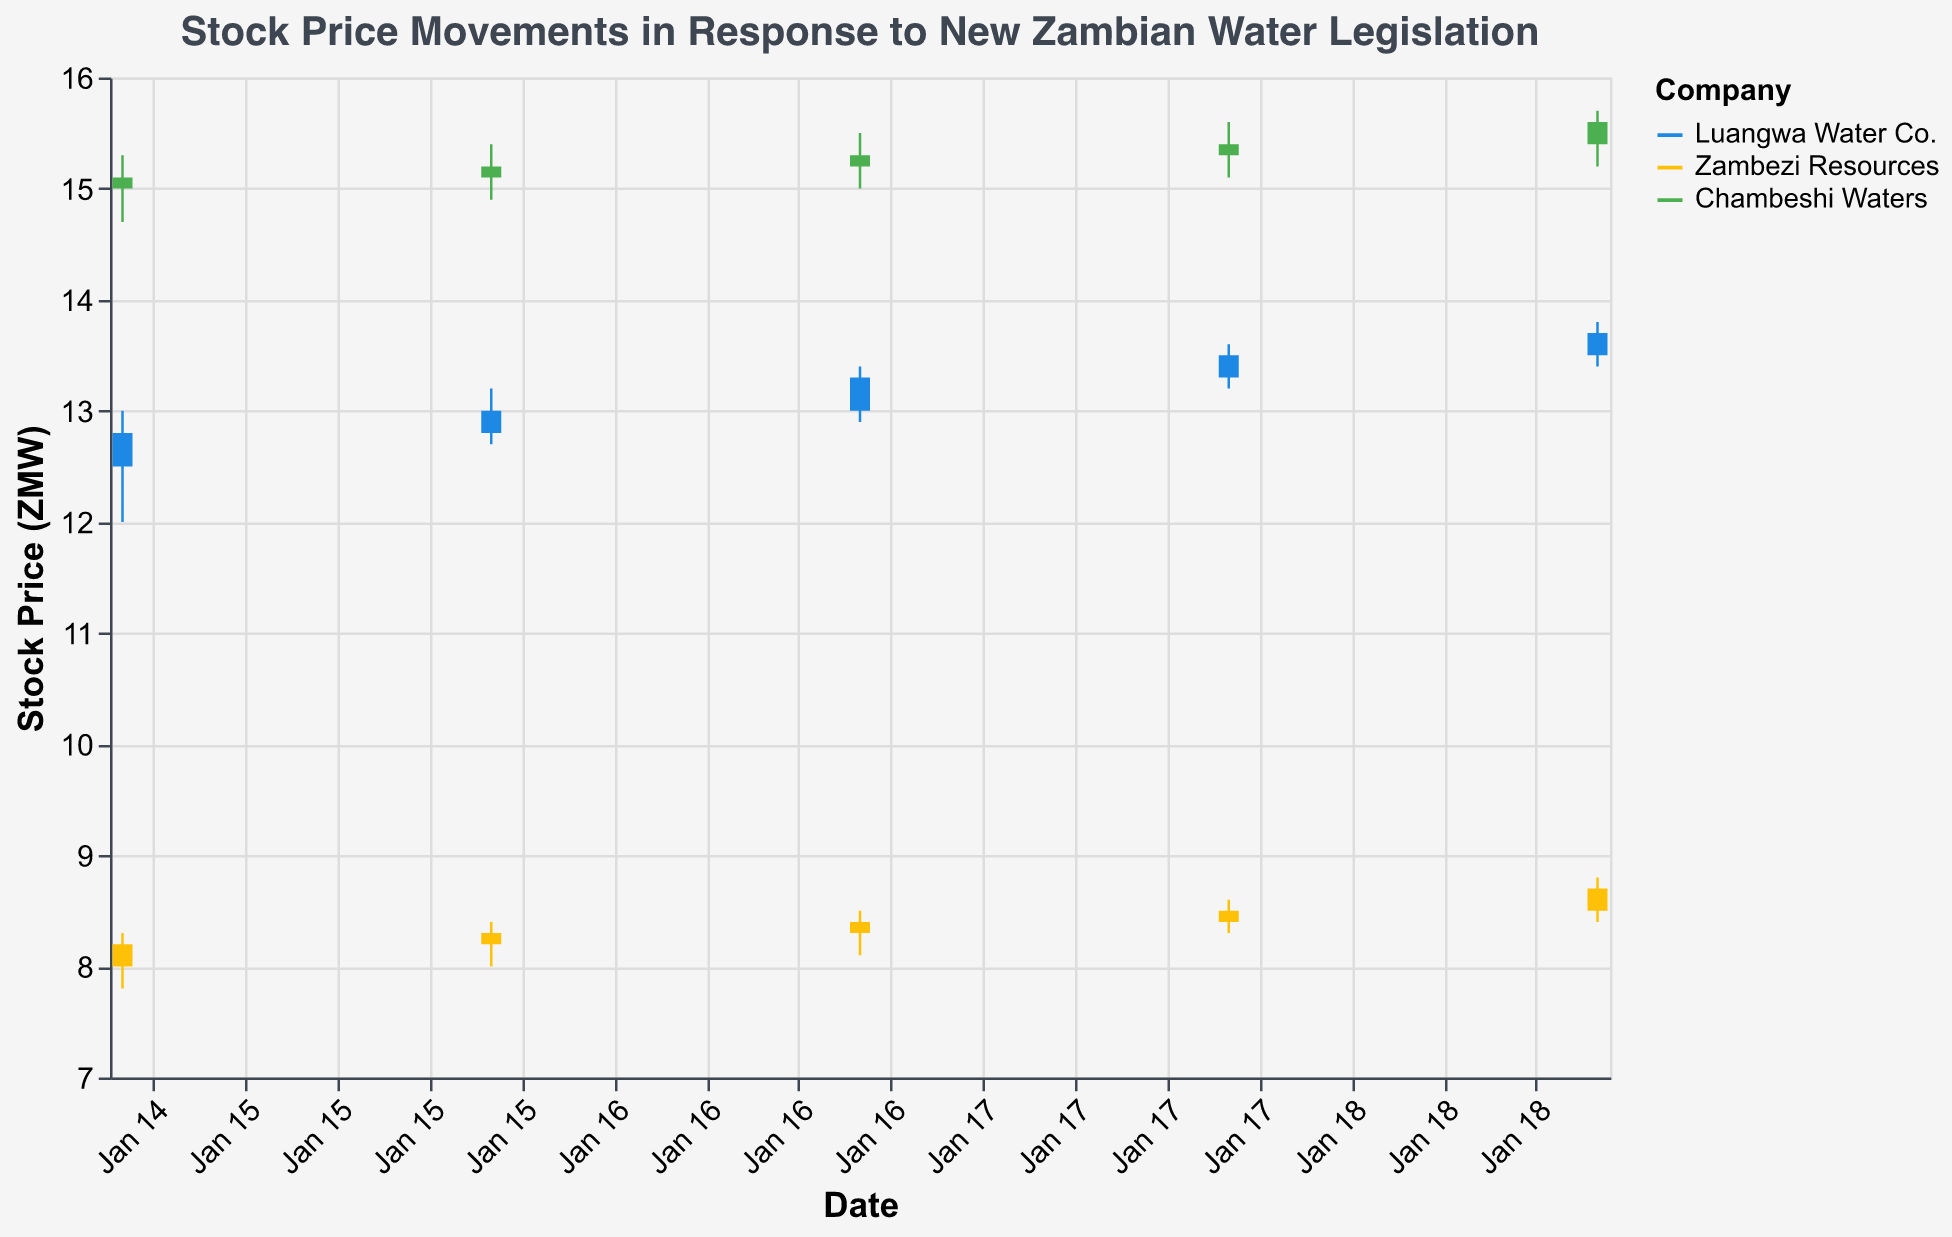What is the highest stock price of Luangwa Water Co. on January 19, 2023? The highest stock price of Luangwa Water Co. on January 19, 2023, is visually located at the peak of the candlestick for that date. The highest value recorded is 13.8 ZMW.
Answer: 13.8 ZMW Among the three companies, which one had the highest closing price on January 16, 2023? To determine the highest closing price among the three companies, compare the closing values on January 16, 2023: Luangwa Water Co. (13.0 ZMW), Zambezi Resources (8.3 ZMW), and Chambeshi Waters (15.2 ZMW). Chambeshi Waters has the highest closing price.
Answer: Chambeshi Waters What is the average opening price of Zambezi Resources from January 15 to January 19, 2023? To calculate the average opening price, sum the opening prices of Zambezi Resources from January 15 to January 19, then divide by the number of days: (8.0 + 8.2 + 8.3 + 8.4 + 8.5) / 5 = 41.4 / 5 = 8.28 ZMW.
Answer: 8.28 ZMW Which company showed the most consistent (smallest difference between high and low price each day) stock price movement over the period? To find the most consistent company, calculate the daily price range (High - Low) for each company and average these ranges: Luangwa Water Co. (1.0, 0.5, 0.5, 0.4, 0.4), Zambezi Resources (0.5, 0.4, 0.4, 0.3, 0.4), Chambeshi Waters (0.6, 0.5, 0.5, 0.5, 0.5). Zambezi Resources has the smallest average difference.
Answer: Zambezi Resources How did Chambeshi Waters' closing price trend from January 15 to January 19, 2023? To identify the trend, observe the closing prices of Chambeshi Waters over the days: January 15 (15.1 ZMW), January 16 (15.2 ZMW), January 17 (15.3 ZMW), January 18 (15.4 ZMW), January 19 (15.6 ZMW). The price consistently increased each day, indicating an upward trend.
Answer: Upward trend On which date did Luangwa Water Co. experience the highest trading volume? Examine the trading volumes for Luangwa Water Co. and identify the highest one. Luangwa Water Co. had its highest volume of 15,000 on January 16, 2023.
Answer: January 16, 2023 Which company had the greatest increase in closing price from January 15 to January 19, 2023? Calculate the change in closing prices for each company from January 15 to January 19: Luangwa Water Co. (13.7 - 12.8 = 0.9), Zambezi Resources (8.7 - 8.2 = 0.5), Chambeshi Waters (15.6 - 15.1 = 0.5). Luangwa Water Co. had the greatest increase.
Answer: Luangwa Water Co What is the difference between the highest closing price and the lowest closing price of Chambeshi Waters over the given period? Determine the highest and lowest closing prices of Chambeshi Waters from January 15 to January 19: Highest (15.6 ZMW), Lowest (15.1 ZMW). The difference is 15.6 - 15.1 = 0.5 ZMW.
Answer: 0.5 ZMW For the period from January 15 to January 19, 2023, which company had the highest closing stock price on average? Calculate the average closing prices: Luangwa Water Co. (12.8 + 13.0 + 13.3 + 13.5 + 13.7 = 66.3 / 5 = 13.26 ZMW), Zambezi Resources (8.2 + 8.3 + 8.4 + 8.5 + 8.7 = 42.1 / 5 = 8.42 ZMW), Chambeshi Waters (15.1 + 15.2 + 15.3 + 15.4 + 15.6 = 76.6 / 5 = 15.32 ZMW). Chambeshi Waters has the highest average closing price.
Answer: Chambeshi Waters What was the trading volume trend for Chambeshi Waters during this period? Review the trading volumes for Chambeshi Waters: January 15 (20,000), January 16 (25,000), January 17 (22,000), January 18 (24,000), January 19 (23,000). The trend shows fluctuating volumes with an overall increase from the lowest to the highest point.
Answer: Fluctuating with an increasing trend 